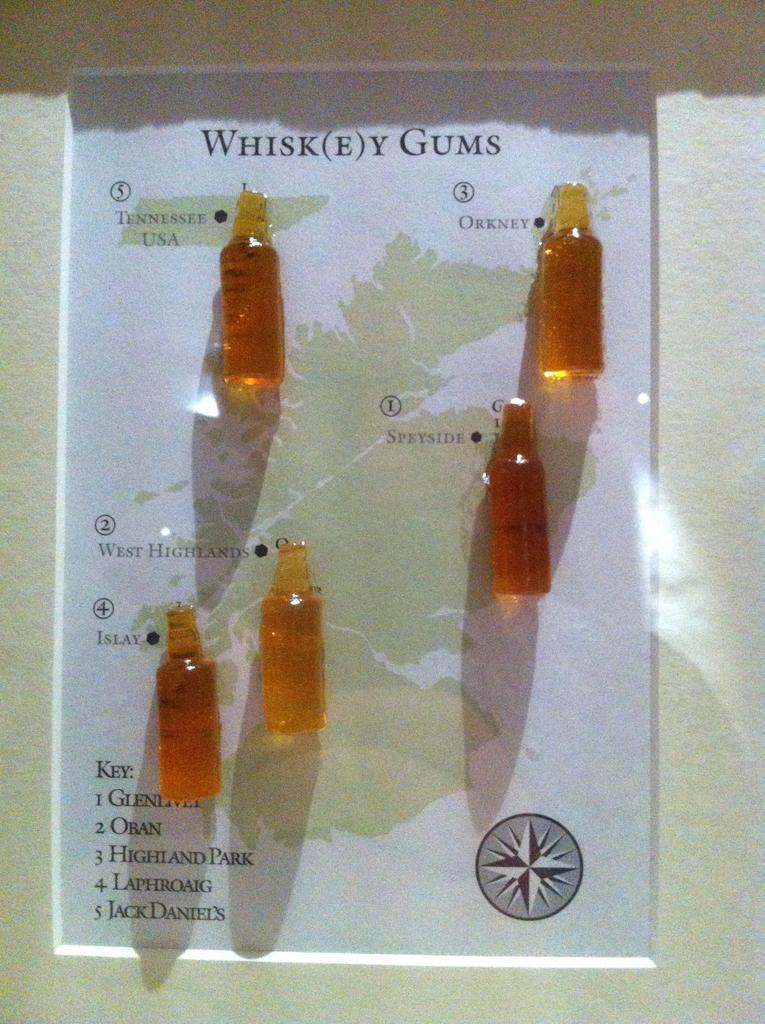Describe this image in one or two sentences. In this image I can see few small bottles. 